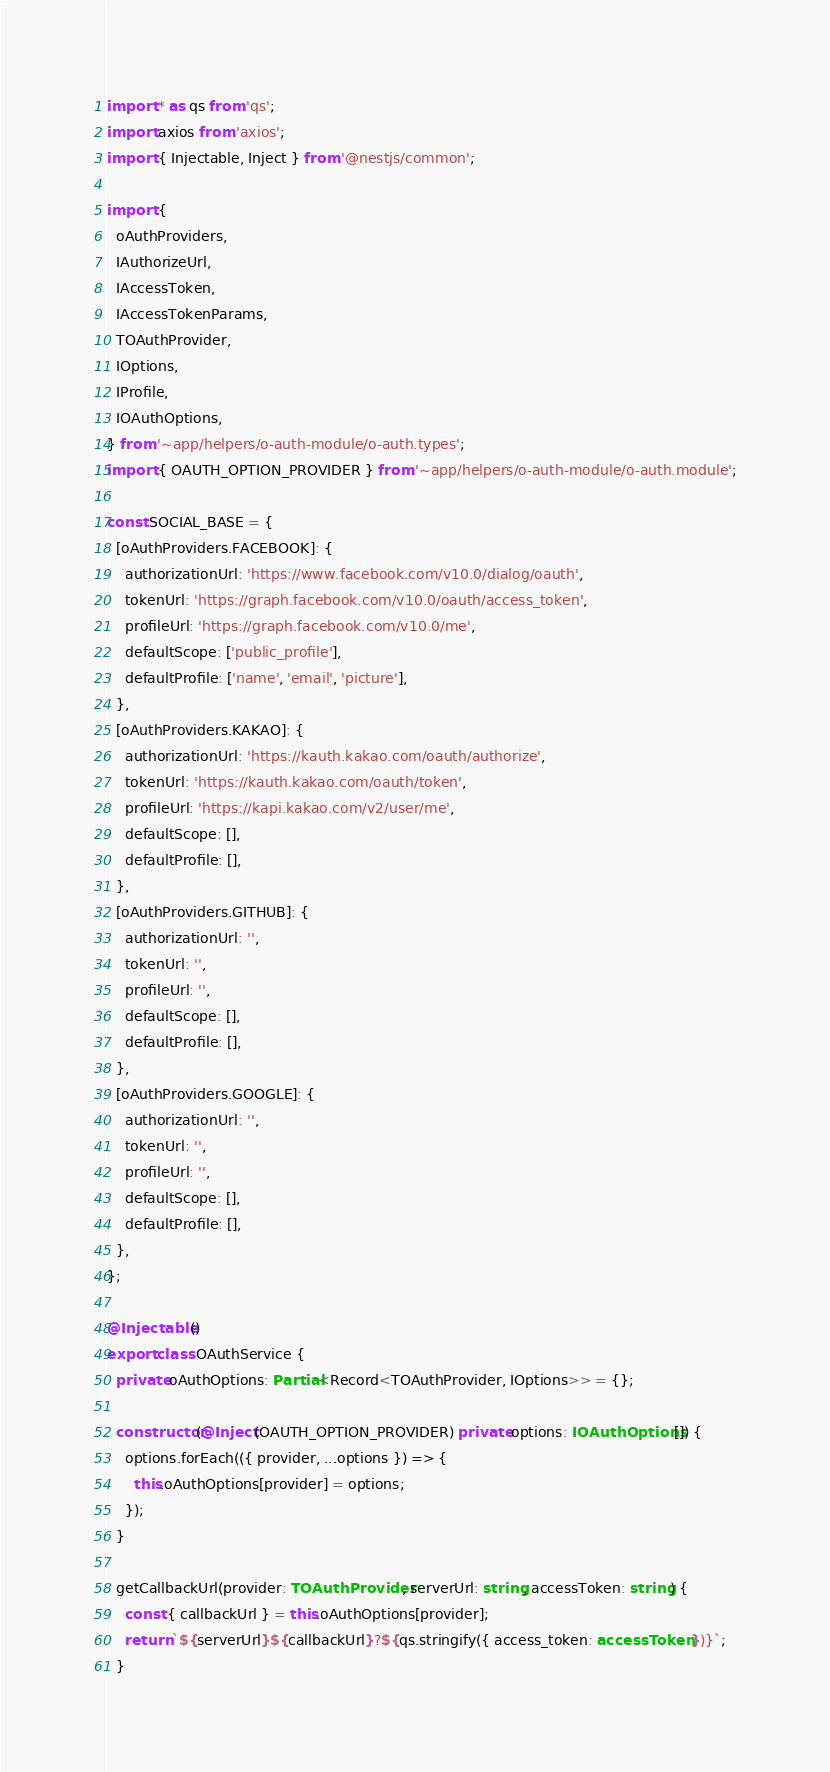Convert code to text. <code><loc_0><loc_0><loc_500><loc_500><_TypeScript_>import * as qs from 'qs';
import axios from 'axios';
import { Injectable, Inject } from '@nestjs/common';

import {
  oAuthProviders,
  IAuthorizeUrl,
  IAccessToken,
  IAccessTokenParams,
  TOAuthProvider,
  IOptions,
  IProfile,
  IOAuthOptions,
} from '~app/helpers/o-auth-module/o-auth.types';
import { OAUTH_OPTION_PROVIDER } from '~app/helpers/o-auth-module/o-auth.module';

const SOCIAL_BASE = {
  [oAuthProviders.FACEBOOK]: {
    authorizationUrl: 'https://www.facebook.com/v10.0/dialog/oauth',
    tokenUrl: 'https://graph.facebook.com/v10.0/oauth/access_token',
    profileUrl: 'https://graph.facebook.com/v10.0/me',
    defaultScope: ['public_profile'],
    defaultProfile: ['name', 'email', 'picture'],
  },
  [oAuthProviders.KAKAO]: {
    authorizationUrl: 'https://kauth.kakao.com/oauth/authorize',
    tokenUrl: 'https://kauth.kakao.com/oauth/token',
    profileUrl: 'https://kapi.kakao.com/v2/user/me',
    defaultScope: [],
    defaultProfile: [],
  },
  [oAuthProviders.GITHUB]: {
    authorizationUrl: '',
    tokenUrl: '',
    profileUrl: '',
    defaultScope: [],
    defaultProfile: [],
  },
  [oAuthProviders.GOOGLE]: {
    authorizationUrl: '',
    tokenUrl: '',
    profileUrl: '',
    defaultScope: [],
    defaultProfile: [],
  },
};

@Injectable()
export class OAuthService {
  private oAuthOptions: Partial<Record<TOAuthProvider, IOptions>> = {};

  constructor(@Inject(OAUTH_OPTION_PROVIDER) private options: IOAuthOptions[]) {
    options.forEach(({ provider, ...options }) => {
      this.oAuthOptions[provider] = options;
    });
  }

  getCallbackUrl(provider: TOAuthProvider, serverUrl: string, accessToken: string) {
    const { callbackUrl } = this.oAuthOptions[provider];
    return `${serverUrl}${callbackUrl}?${qs.stringify({ access_token: accessToken })}`;
  }
</code> 